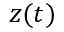Convert formula to latex. <formula><loc_0><loc_0><loc_500><loc_500>z ( t )</formula> 